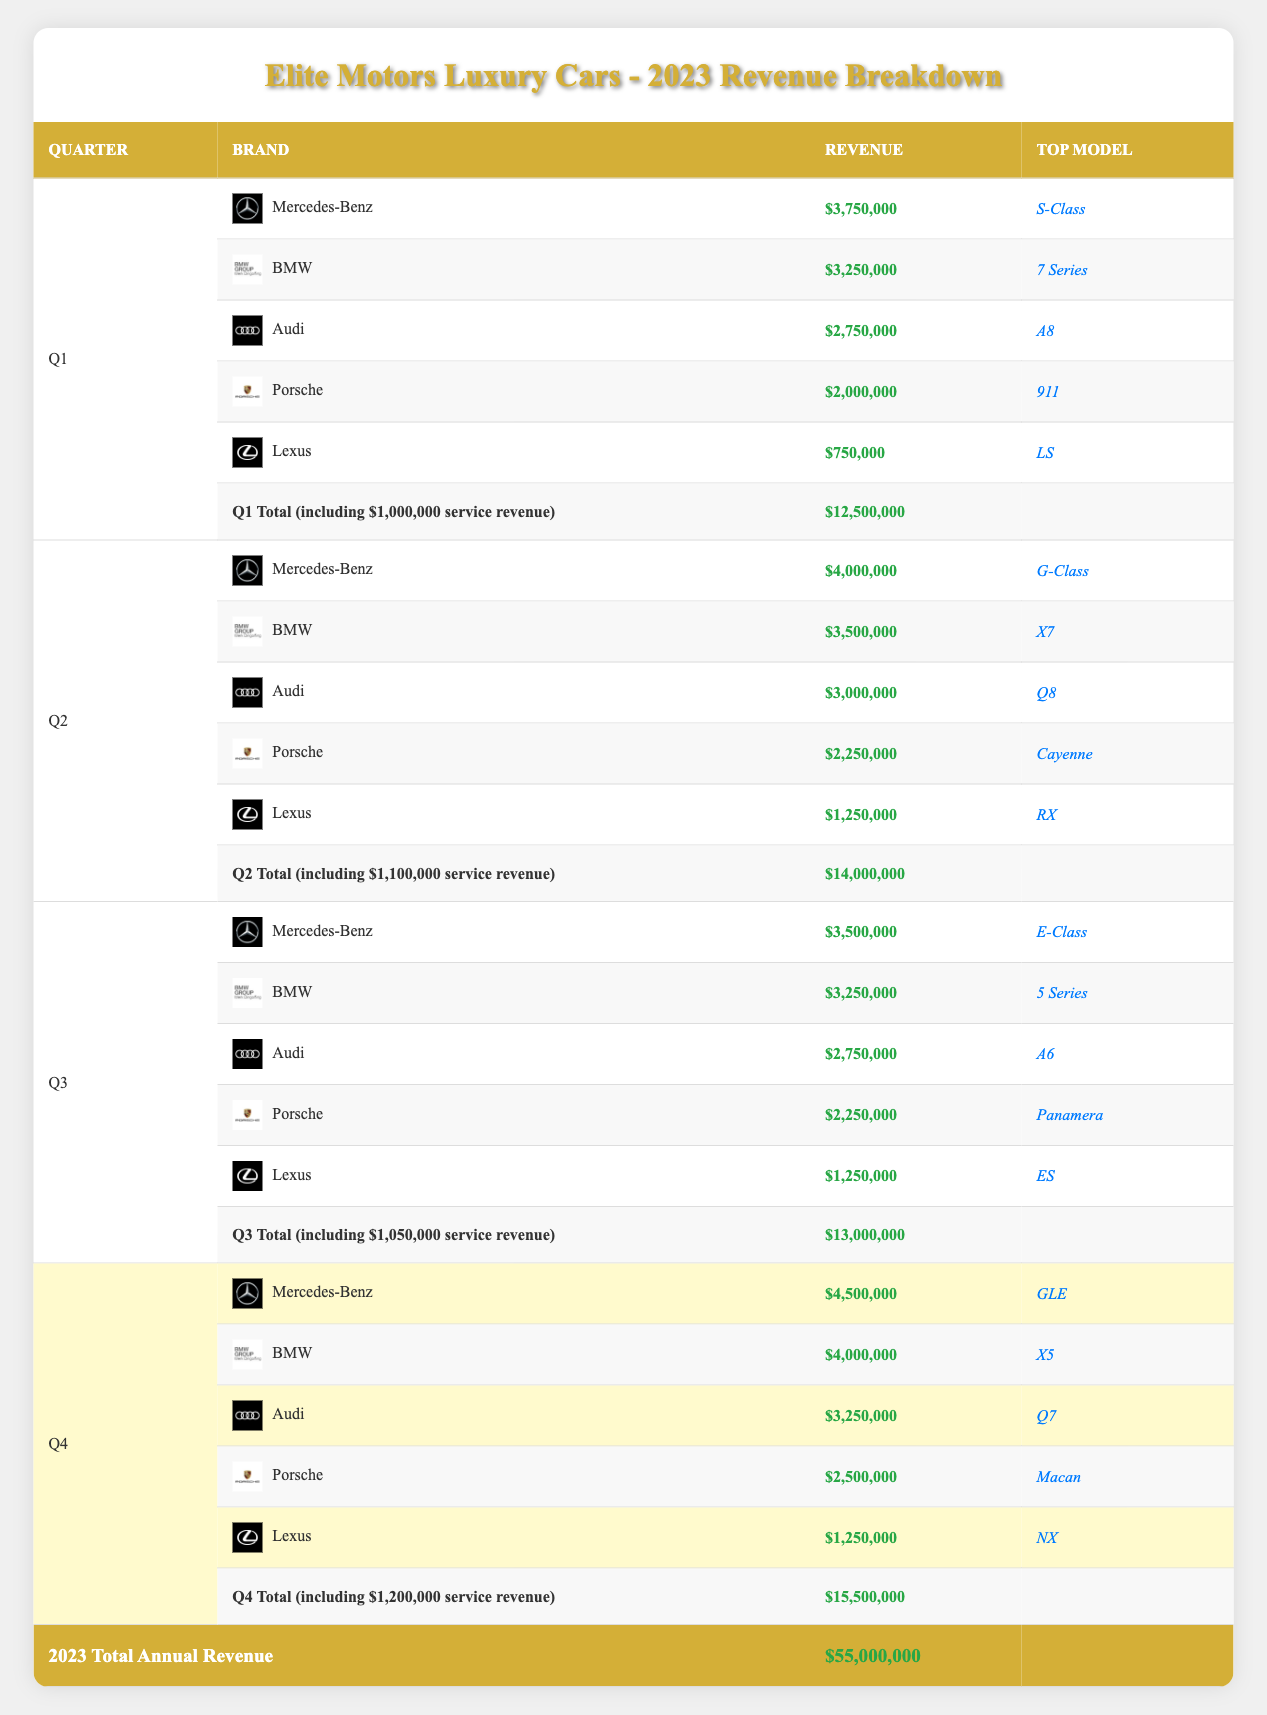What was the total revenue for Q2? The total revenue for Q2 is listed in the table as $14,000,000.
Answer: $14,000,000 Which brand generated the highest revenue in Q3? The table shows that Mercedes-Benz earned $3,500,000 in Q3, which is higher than the other brands listed.
Answer: Mercedes-Benz What was the overall annual revenue for 2023? According to the table's annual total row, the overall revenue for 2023 is $55,000,000.
Answer: $55,000,000 Did Porsche have the same revenue in Q1 and Q3? In Q1, Porsche generated $2,000,000, while in Q3, it generated $2,250,000. Since these amounts differ, the answer is no.
Answer: No Which quarter had the highest revenue, and what was the amount? The table shows that Q4 had the highest revenue of $15,500,000.
Answer: Q4: $15,500,000 What is the total revenue generated by Lexus across all quarters? Lexus earned $750,000 in Q1, $1,250,000 in Q2, $1,250,000 in Q3, and $1,250,000 in Q4. Summing these amounts gives $750,000 + $1,250,000 + $1,250,000 + $1,250,000 = $4,500,000.
Answer: $4,500,000 Was the service revenue in Q2 higher than in Q3? The service revenue for Q2 is $1,100,000, whereas for Q3 it is $1,050,000. Since $1,100,000 > $1,050,000, the answer is yes.
Answer: Yes What is the average revenue generated by BMW across all quarters? BMW's revenues are $3,250,000 in Q1, $3,500,000 in Q2, $3,250,000 in Q3, and $4,000,000 in Q4. Adding these gives $3,250,000 + $3,500,000 + $3,250,000 + $4,000,000 = $14,000,000. Dividing by 4 (the number of quarters) gives $14,000,000 / 4 = $3,500,000.
Answer: $3,500,000 Which quarter saw the most sales from Audi? In the table, Audi earned $2,750,000 in Q1, $3,000,000 in Q2, $2,750,000 in Q3, and $3,250,000 in Q4. The highest revenue from Audi in Q4, at $3,250,000, is greater than the others.
Answer: Q4 